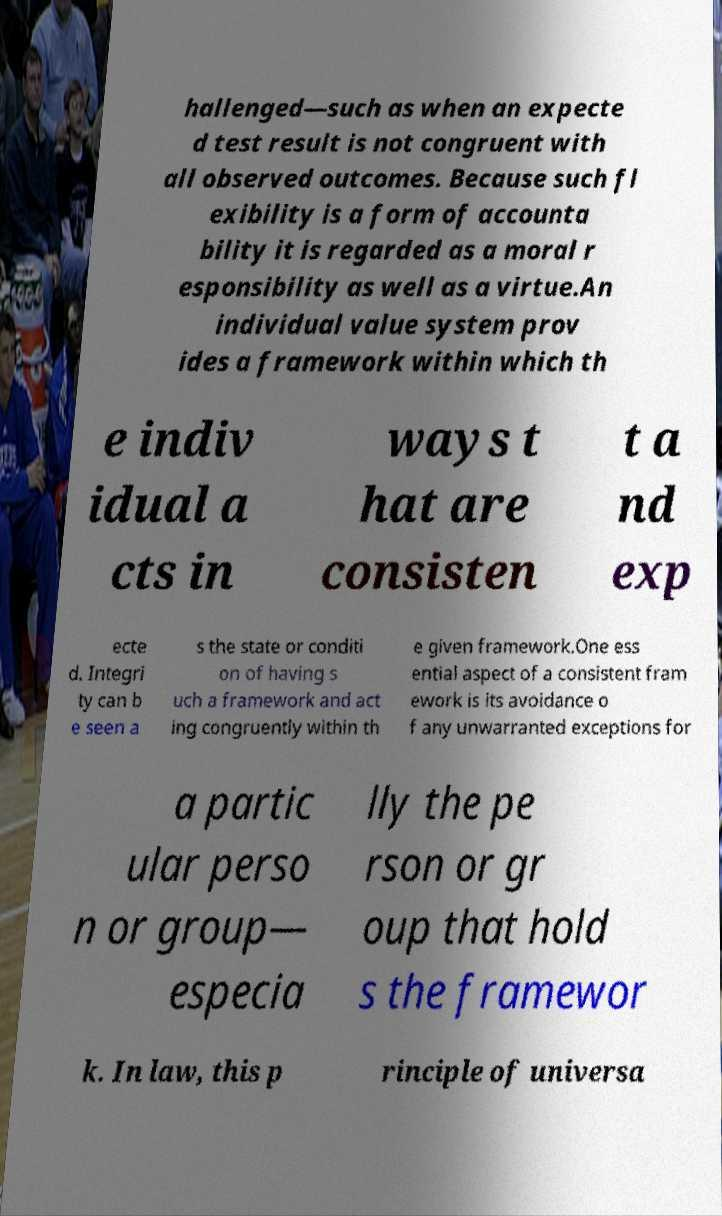Could you assist in decoding the text presented in this image and type it out clearly? hallenged—such as when an expecte d test result is not congruent with all observed outcomes. Because such fl exibility is a form of accounta bility it is regarded as a moral r esponsibility as well as a virtue.An individual value system prov ides a framework within which th e indiv idual a cts in ways t hat are consisten t a nd exp ecte d. Integri ty can b e seen a s the state or conditi on of having s uch a framework and act ing congruently within th e given framework.One ess ential aspect of a consistent fram ework is its avoidance o f any unwarranted exceptions for a partic ular perso n or group— especia lly the pe rson or gr oup that hold s the framewor k. In law, this p rinciple of universa 